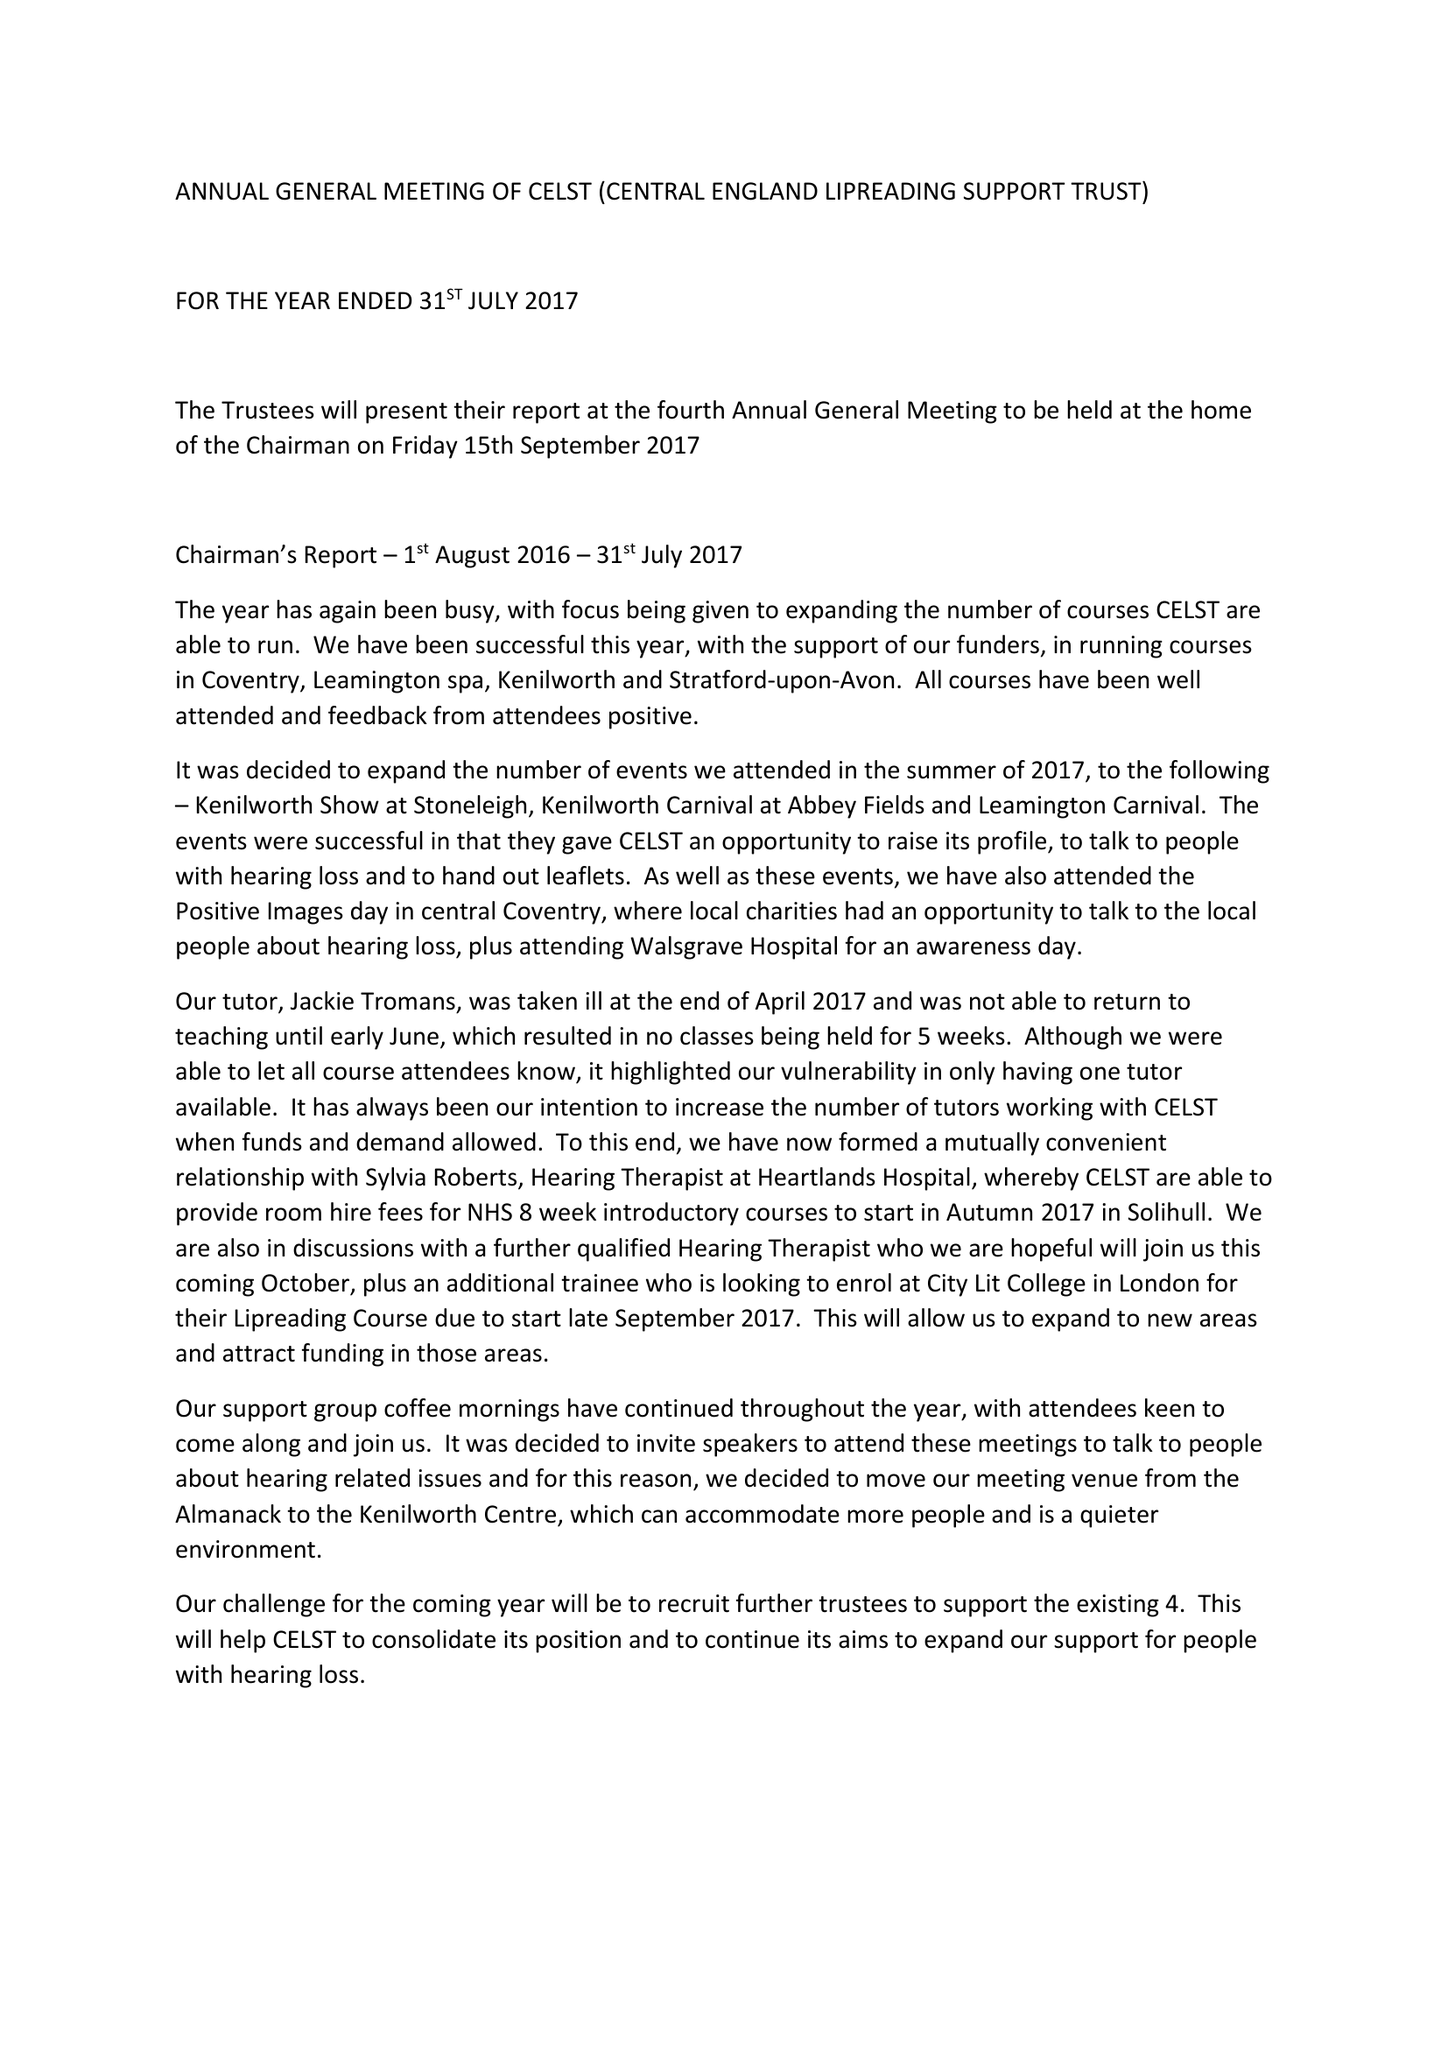What is the value for the address__postcode?
Answer the question using a single word or phrase. CV8 2AE 